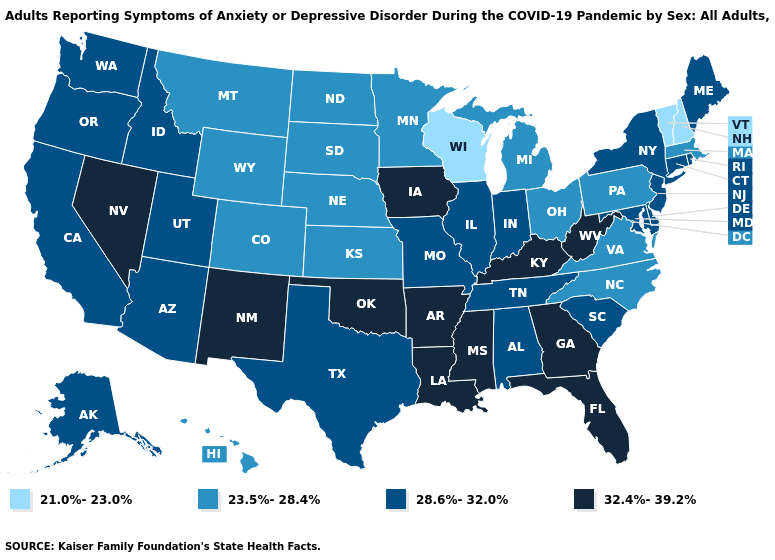Is the legend a continuous bar?
Keep it brief. No. What is the lowest value in the USA?
Keep it brief. 21.0%-23.0%. Does Nebraska have a lower value than Texas?
Concise answer only. Yes. What is the value of New Hampshire?
Keep it brief. 21.0%-23.0%. Name the states that have a value in the range 23.5%-28.4%?
Short answer required. Colorado, Hawaii, Kansas, Massachusetts, Michigan, Minnesota, Montana, Nebraska, North Carolina, North Dakota, Ohio, Pennsylvania, South Dakota, Virginia, Wyoming. What is the value of California?
Answer briefly. 28.6%-32.0%. Does Vermont have the lowest value in the USA?
Short answer required. Yes. Does Florida have the highest value in the USA?
Keep it brief. Yes. Among the states that border Florida , which have the lowest value?
Concise answer only. Alabama. What is the lowest value in states that border Iowa?
Keep it brief. 21.0%-23.0%. What is the value of Nebraska?
Write a very short answer. 23.5%-28.4%. What is the highest value in states that border Michigan?
Give a very brief answer. 28.6%-32.0%. Name the states that have a value in the range 28.6%-32.0%?
Write a very short answer. Alabama, Alaska, Arizona, California, Connecticut, Delaware, Idaho, Illinois, Indiana, Maine, Maryland, Missouri, New Jersey, New York, Oregon, Rhode Island, South Carolina, Tennessee, Texas, Utah, Washington. Does Indiana have the lowest value in the MidWest?
Short answer required. No. 